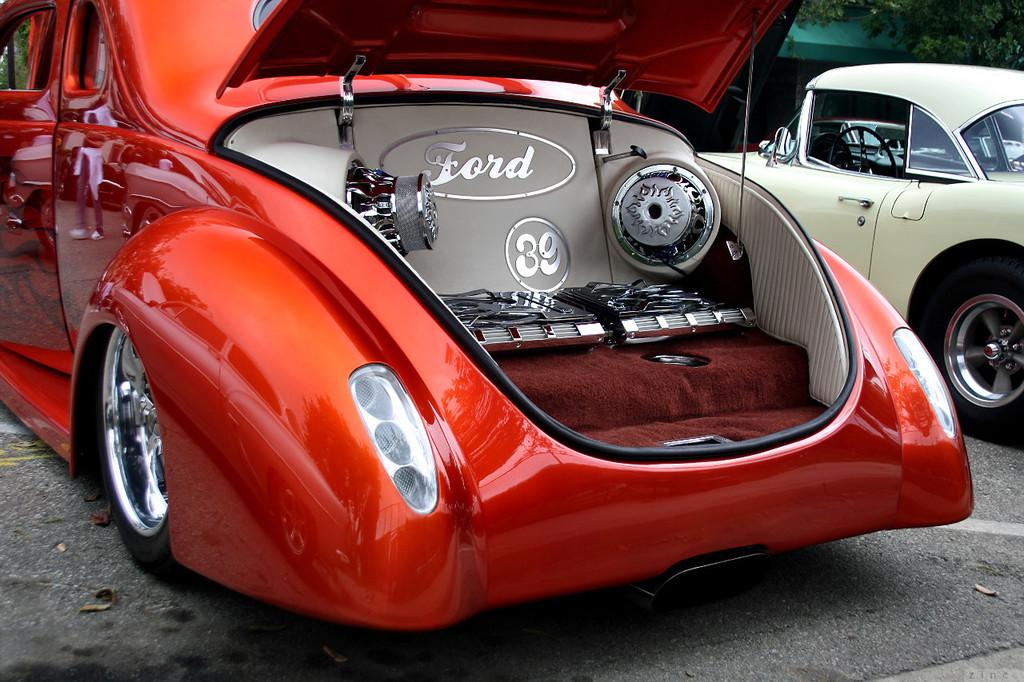<image>
Offer a succinct explanation of the picture presented. The inside of a trunk reads Ford 39 